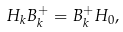Convert formula to latex. <formula><loc_0><loc_0><loc_500><loc_500>H _ { k } B _ { k } ^ { + } = B _ { k } ^ { + } H _ { 0 } ,</formula> 